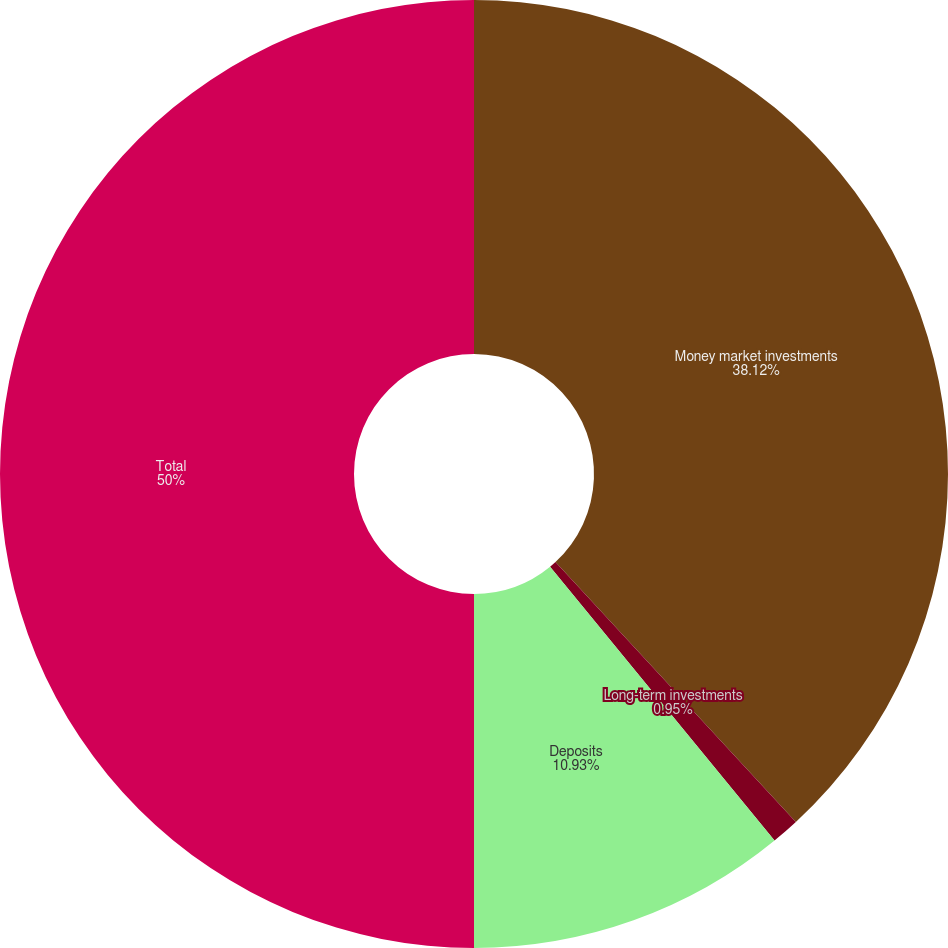<chart> <loc_0><loc_0><loc_500><loc_500><pie_chart><fcel>Money market investments<fcel>Long-term investments<fcel>Deposits<fcel>Total<nl><fcel>38.12%<fcel>0.95%<fcel>10.93%<fcel>50.0%<nl></chart> 